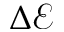<formula> <loc_0><loc_0><loc_500><loc_500>\Delta \mathcal { E }</formula> 